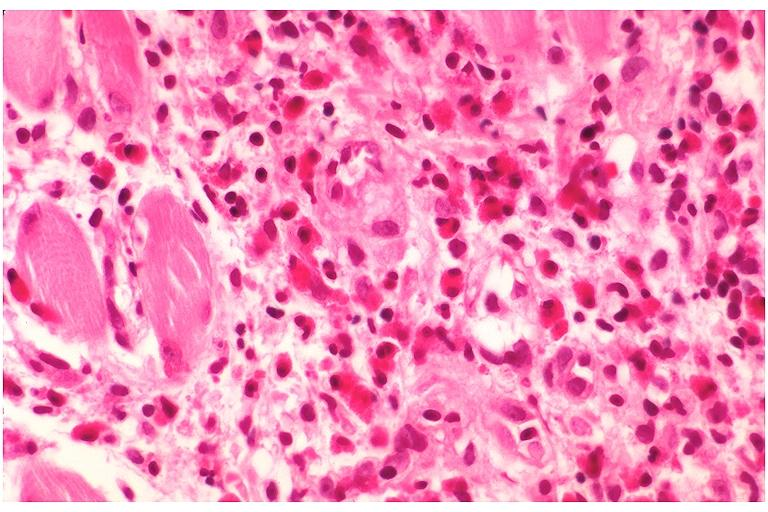what is present?
Answer the question using a single word or phrase. Oral 